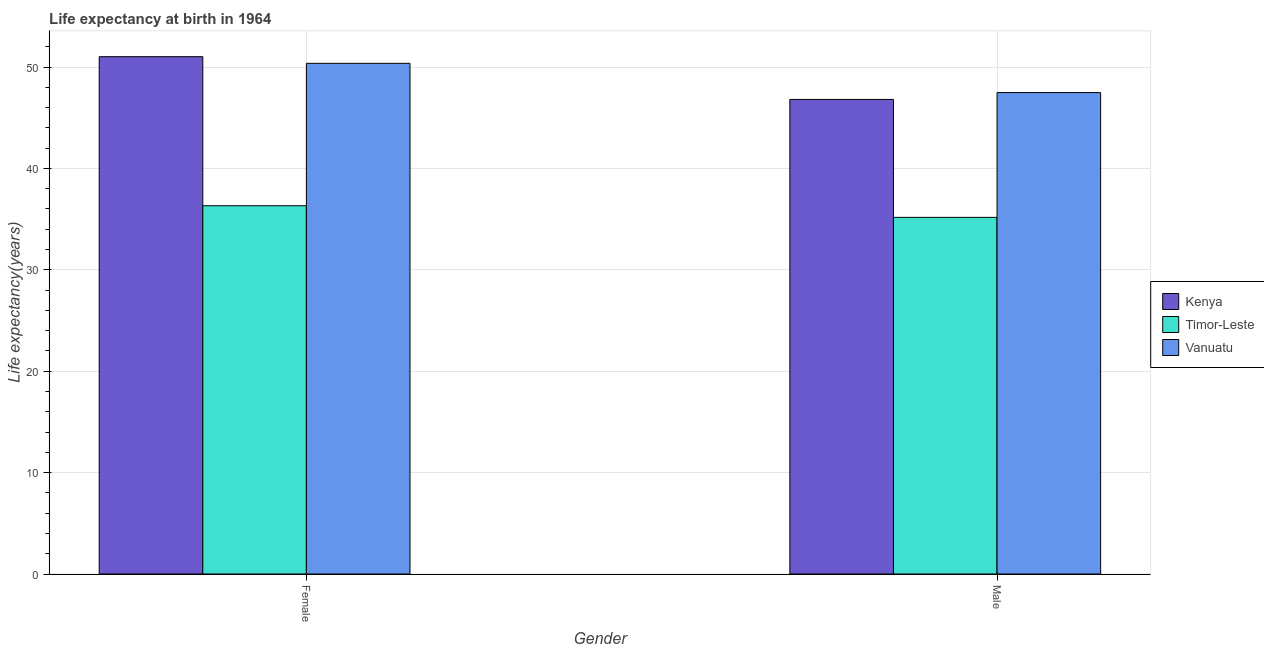Are the number of bars per tick equal to the number of legend labels?
Keep it short and to the point. Yes. Are the number of bars on each tick of the X-axis equal?
Keep it short and to the point. Yes. How many bars are there on the 1st tick from the left?
Keep it short and to the point. 3. What is the label of the 2nd group of bars from the left?
Your response must be concise. Male. What is the life expectancy(female) in Timor-Leste?
Your response must be concise. 36.32. Across all countries, what is the maximum life expectancy(female)?
Your response must be concise. 51.02. Across all countries, what is the minimum life expectancy(male)?
Your response must be concise. 35.17. In which country was the life expectancy(female) maximum?
Keep it short and to the point. Kenya. In which country was the life expectancy(female) minimum?
Ensure brevity in your answer.  Timor-Leste. What is the total life expectancy(male) in the graph?
Give a very brief answer. 129.46. What is the difference between the life expectancy(female) in Kenya and that in Vanuatu?
Make the answer very short. 0.66. What is the difference between the life expectancy(male) in Timor-Leste and the life expectancy(female) in Kenya?
Give a very brief answer. -15.85. What is the average life expectancy(female) per country?
Provide a short and direct response. 45.9. What is the difference between the life expectancy(female) and life expectancy(male) in Timor-Leste?
Provide a short and direct response. 1.15. In how many countries, is the life expectancy(male) greater than 46 years?
Provide a short and direct response. 2. What is the ratio of the life expectancy(female) in Timor-Leste to that in Vanuatu?
Make the answer very short. 0.72. Is the life expectancy(female) in Kenya less than that in Timor-Leste?
Your answer should be compact. No. What does the 2nd bar from the left in Male represents?
Make the answer very short. Timor-Leste. What does the 2nd bar from the right in Male represents?
Offer a very short reply. Timor-Leste. Are all the bars in the graph horizontal?
Offer a terse response. No. How many countries are there in the graph?
Keep it short and to the point. 3. What is the difference between two consecutive major ticks on the Y-axis?
Ensure brevity in your answer.  10. Where does the legend appear in the graph?
Ensure brevity in your answer.  Center right. What is the title of the graph?
Offer a terse response. Life expectancy at birth in 1964. What is the label or title of the Y-axis?
Your answer should be compact. Life expectancy(years). What is the Life expectancy(years) in Kenya in Female?
Give a very brief answer. 51.02. What is the Life expectancy(years) of Timor-Leste in Female?
Offer a terse response. 36.32. What is the Life expectancy(years) in Vanuatu in Female?
Provide a succinct answer. 50.36. What is the Life expectancy(years) of Kenya in Male?
Make the answer very short. 46.8. What is the Life expectancy(years) of Timor-Leste in Male?
Keep it short and to the point. 35.17. What is the Life expectancy(years) of Vanuatu in Male?
Your answer should be compact. 47.48. Across all Gender, what is the maximum Life expectancy(years) of Kenya?
Provide a short and direct response. 51.02. Across all Gender, what is the maximum Life expectancy(years) in Timor-Leste?
Give a very brief answer. 36.32. Across all Gender, what is the maximum Life expectancy(years) of Vanuatu?
Your answer should be compact. 50.36. Across all Gender, what is the minimum Life expectancy(years) of Kenya?
Offer a terse response. 46.8. Across all Gender, what is the minimum Life expectancy(years) of Timor-Leste?
Provide a succinct answer. 35.17. Across all Gender, what is the minimum Life expectancy(years) in Vanuatu?
Offer a terse response. 47.48. What is the total Life expectancy(years) in Kenya in the graph?
Your response must be concise. 97.83. What is the total Life expectancy(years) in Timor-Leste in the graph?
Provide a succinct answer. 71.5. What is the total Life expectancy(years) of Vanuatu in the graph?
Ensure brevity in your answer.  97.84. What is the difference between the Life expectancy(years) in Kenya in Female and that in Male?
Make the answer very short. 4.21. What is the difference between the Life expectancy(years) of Timor-Leste in Female and that in Male?
Your response must be concise. 1.15. What is the difference between the Life expectancy(years) of Vanuatu in Female and that in Male?
Your response must be concise. 2.88. What is the difference between the Life expectancy(years) of Kenya in Female and the Life expectancy(years) of Timor-Leste in Male?
Your response must be concise. 15.85. What is the difference between the Life expectancy(years) in Kenya in Female and the Life expectancy(years) in Vanuatu in Male?
Ensure brevity in your answer.  3.54. What is the difference between the Life expectancy(years) in Timor-Leste in Female and the Life expectancy(years) in Vanuatu in Male?
Provide a succinct answer. -11.16. What is the average Life expectancy(years) in Kenya per Gender?
Provide a short and direct response. 48.91. What is the average Life expectancy(years) of Timor-Leste per Gender?
Your response must be concise. 35.75. What is the average Life expectancy(years) in Vanuatu per Gender?
Your response must be concise. 48.92. What is the difference between the Life expectancy(years) in Kenya and Life expectancy(years) in Timor-Leste in Female?
Your response must be concise. 14.7. What is the difference between the Life expectancy(years) in Kenya and Life expectancy(years) in Vanuatu in Female?
Offer a very short reply. 0.66. What is the difference between the Life expectancy(years) of Timor-Leste and Life expectancy(years) of Vanuatu in Female?
Give a very brief answer. -14.04. What is the difference between the Life expectancy(years) in Kenya and Life expectancy(years) in Timor-Leste in Male?
Your answer should be compact. 11.63. What is the difference between the Life expectancy(years) of Kenya and Life expectancy(years) of Vanuatu in Male?
Offer a terse response. -0.68. What is the difference between the Life expectancy(years) in Timor-Leste and Life expectancy(years) in Vanuatu in Male?
Your answer should be very brief. -12.31. What is the ratio of the Life expectancy(years) of Kenya in Female to that in Male?
Offer a terse response. 1.09. What is the ratio of the Life expectancy(years) of Timor-Leste in Female to that in Male?
Provide a short and direct response. 1.03. What is the ratio of the Life expectancy(years) in Vanuatu in Female to that in Male?
Make the answer very short. 1.06. What is the difference between the highest and the second highest Life expectancy(years) of Kenya?
Give a very brief answer. 4.21. What is the difference between the highest and the second highest Life expectancy(years) in Timor-Leste?
Provide a short and direct response. 1.15. What is the difference between the highest and the second highest Life expectancy(years) of Vanuatu?
Your answer should be compact. 2.88. What is the difference between the highest and the lowest Life expectancy(years) in Kenya?
Offer a very short reply. 4.21. What is the difference between the highest and the lowest Life expectancy(years) of Timor-Leste?
Keep it short and to the point. 1.15. What is the difference between the highest and the lowest Life expectancy(years) of Vanuatu?
Provide a succinct answer. 2.88. 